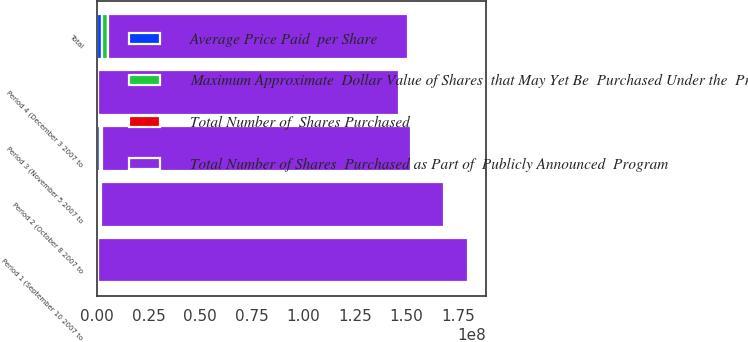Convert chart to OTSL. <chart><loc_0><loc_0><loc_500><loc_500><stacked_bar_chart><ecel><fcel>Period 1 (September 10 2007 to<fcel>Period 2 (October 8 2007 to<fcel>Period 3 (November 5 2007 to<fcel>Period 4 (December 3 2007 to<fcel>Total<nl><fcel>Average Price Paid  per Share<fcel>153500<fcel>879350<fcel>1.2111e+06<fcel>317400<fcel>2.56135e+06<nl><fcel>Total Number of  Shares Purchased<fcel>17.33<fcel>14.7<fcel>13.82<fcel>12.88<fcel>14.22<nl><fcel>Maximum Approximate  Dollar Value of Shares  that May Yet Be  Purchased Under the  Program<fcel>153500<fcel>879350<fcel>1.2111e+06<fcel>317400<fcel>2.56135e+06<nl><fcel>Total Number of Shares  Purchased as Part of  Publicly Announced  Program<fcel>1.79353e+08<fcel>1.66422e+08<fcel>1.49683e+08<fcel>1.45595e+08<fcel>1.45595e+08<nl></chart> 